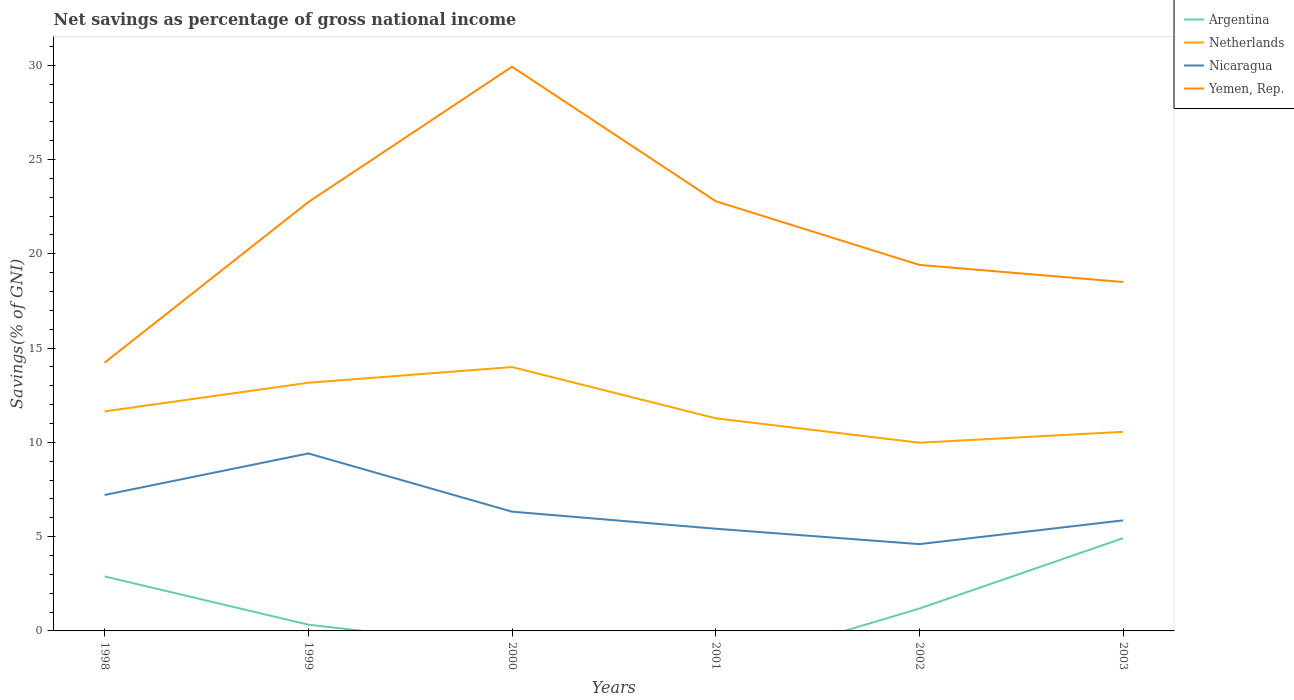Across all years, what is the maximum total savings in Netherlands?
Ensure brevity in your answer.  9.98. What is the total total savings in Nicaragua in the graph?
Offer a terse response. 0.89. What is the difference between the highest and the second highest total savings in Argentina?
Ensure brevity in your answer.  4.92. Is the total savings in Argentina strictly greater than the total savings in Netherlands over the years?
Provide a succinct answer. Yes. How many lines are there?
Give a very brief answer. 4. How many years are there in the graph?
Provide a short and direct response. 6. What is the difference between two consecutive major ticks on the Y-axis?
Offer a very short reply. 5. Are the values on the major ticks of Y-axis written in scientific E-notation?
Provide a short and direct response. No. Does the graph contain any zero values?
Offer a terse response. Yes. How many legend labels are there?
Ensure brevity in your answer.  4. How are the legend labels stacked?
Give a very brief answer. Vertical. What is the title of the graph?
Your answer should be compact. Net savings as percentage of gross national income. What is the label or title of the X-axis?
Keep it short and to the point. Years. What is the label or title of the Y-axis?
Your response must be concise. Savings(% of GNI). What is the Savings(% of GNI) of Argentina in 1998?
Ensure brevity in your answer.  2.89. What is the Savings(% of GNI) in Netherlands in 1998?
Ensure brevity in your answer.  11.64. What is the Savings(% of GNI) in Nicaragua in 1998?
Make the answer very short. 7.21. What is the Savings(% of GNI) in Yemen, Rep. in 1998?
Your response must be concise. 14.23. What is the Savings(% of GNI) of Argentina in 1999?
Keep it short and to the point. 0.33. What is the Savings(% of GNI) in Netherlands in 1999?
Make the answer very short. 13.16. What is the Savings(% of GNI) in Nicaragua in 1999?
Offer a very short reply. 9.41. What is the Savings(% of GNI) in Yemen, Rep. in 1999?
Give a very brief answer. 22.74. What is the Savings(% of GNI) of Netherlands in 2000?
Make the answer very short. 13.99. What is the Savings(% of GNI) of Nicaragua in 2000?
Keep it short and to the point. 6.33. What is the Savings(% of GNI) in Yemen, Rep. in 2000?
Provide a short and direct response. 29.92. What is the Savings(% of GNI) of Argentina in 2001?
Offer a very short reply. 0. What is the Savings(% of GNI) in Netherlands in 2001?
Keep it short and to the point. 11.28. What is the Savings(% of GNI) in Nicaragua in 2001?
Give a very brief answer. 5.42. What is the Savings(% of GNI) of Yemen, Rep. in 2001?
Your answer should be compact. 22.79. What is the Savings(% of GNI) in Argentina in 2002?
Your answer should be very brief. 1.19. What is the Savings(% of GNI) of Netherlands in 2002?
Offer a very short reply. 9.98. What is the Savings(% of GNI) in Nicaragua in 2002?
Provide a succinct answer. 4.6. What is the Savings(% of GNI) in Yemen, Rep. in 2002?
Your response must be concise. 19.41. What is the Savings(% of GNI) in Argentina in 2003?
Offer a very short reply. 4.92. What is the Savings(% of GNI) of Netherlands in 2003?
Provide a succinct answer. 10.56. What is the Savings(% of GNI) of Nicaragua in 2003?
Provide a short and direct response. 5.86. What is the Savings(% of GNI) of Yemen, Rep. in 2003?
Your response must be concise. 18.51. Across all years, what is the maximum Savings(% of GNI) of Argentina?
Provide a succinct answer. 4.92. Across all years, what is the maximum Savings(% of GNI) in Netherlands?
Ensure brevity in your answer.  13.99. Across all years, what is the maximum Savings(% of GNI) in Nicaragua?
Offer a very short reply. 9.41. Across all years, what is the maximum Savings(% of GNI) in Yemen, Rep.?
Your answer should be very brief. 29.92. Across all years, what is the minimum Savings(% of GNI) in Argentina?
Ensure brevity in your answer.  0. Across all years, what is the minimum Savings(% of GNI) of Netherlands?
Offer a terse response. 9.98. Across all years, what is the minimum Savings(% of GNI) of Nicaragua?
Your answer should be compact. 4.6. Across all years, what is the minimum Savings(% of GNI) of Yemen, Rep.?
Ensure brevity in your answer.  14.23. What is the total Savings(% of GNI) in Argentina in the graph?
Give a very brief answer. 9.33. What is the total Savings(% of GNI) of Netherlands in the graph?
Your answer should be very brief. 70.62. What is the total Savings(% of GNI) in Nicaragua in the graph?
Make the answer very short. 38.83. What is the total Savings(% of GNI) of Yemen, Rep. in the graph?
Your answer should be compact. 127.6. What is the difference between the Savings(% of GNI) in Argentina in 1998 and that in 1999?
Give a very brief answer. 2.56. What is the difference between the Savings(% of GNI) in Netherlands in 1998 and that in 1999?
Keep it short and to the point. -1.52. What is the difference between the Savings(% of GNI) of Nicaragua in 1998 and that in 1999?
Your response must be concise. -2.2. What is the difference between the Savings(% of GNI) of Yemen, Rep. in 1998 and that in 1999?
Give a very brief answer. -8.51. What is the difference between the Savings(% of GNI) of Netherlands in 1998 and that in 2000?
Give a very brief answer. -2.35. What is the difference between the Savings(% of GNI) of Nicaragua in 1998 and that in 2000?
Offer a very short reply. 0.89. What is the difference between the Savings(% of GNI) in Yemen, Rep. in 1998 and that in 2000?
Make the answer very short. -15.7. What is the difference between the Savings(% of GNI) in Netherlands in 1998 and that in 2001?
Your answer should be compact. 0.37. What is the difference between the Savings(% of GNI) of Nicaragua in 1998 and that in 2001?
Your answer should be compact. 1.79. What is the difference between the Savings(% of GNI) in Yemen, Rep. in 1998 and that in 2001?
Your response must be concise. -8.56. What is the difference between the Savings(% of GNI) of Argentina in 1998 and that in 2002?
Give a very brief answer. 1.7. What is the difference between the Savings(% of GNI) in Netherlands in 1998 and that in 2002?
Your answer should be compact. 1.66. What is the difference between the Savings(% of GNI) in Nicaragua in 1998 and that in 2002?
Give a very brief answer. 2.61. What is the difference between the Savings(% of GNI) in Yemen, Rep. in 1998 and that in 2002?
Provide a succinct answer. -5.18. What is the difference between the Savings(% of GNI) in Argentina in 1998 and that in 2003?
Your answer should be compact. -2.03. What is the difference between the Savings(% of GNI) of Netherlands in 1998 and that in 2003?
Your answer should be very brief. 1.08. What is the difference between the Savings(% of GNI) in Nicaragua in 1998 and that in 2003?
Ensure brevity in your answer.  1.35. What is the difference between the Savings(% of GNI) of Yemen, Rep. in 1998 and that in 2003?
Make the answer very short. -4.28. What is the difference between the Savings(% of GNI) of Netherlands in 1999 and that in 2000?
Provide a short and direct response. -0.83. What is the difference between the Savings(% of GNI) of Nicaragua in 1999 and that in 2000?
Keep it short and to the point. 3.09. What is the difference between the Savings(% of GNI) of Yemen, Rep. in 1999 and that in 2000?
Offer a very short reply. -7.18. What is the difference between the Savings(% of GNI) of Netherlands in 1999 and that in 2001?
Keep it short and to the point. 1.88. What is the difference between the Savings(% of GNI) in Nicaragua in 1999 and that in 2001?
Make the answer very short. 3.99. What is the difference between the Savings(% of GNI) in Yemen, Rep. in 1999 and that in 2001?
Offer a very short reply. -0.05. What is the difference between the Savings(% of GNI) of Argentina in 1999 and that in 2002?
Offer a very short reply. -0.85. What is the difference between the Savings(% of GNI) of Netherlands in 1999 and that in 2002?
Provide a short and direct response. 3.18. What is the difference between the Savings(% of GNI) in Nicaragua in 1999 and that in 2002?
Offer a terse response. 4.81. What is the difference between the Savings(% of GNI) in Yemen, Rep. in 1999 and that in 2002?
Give a very brief answer. 3.33. What is the difference between the Savings(% of GNI) of Argentina in 1999 and that in 2003?
Ensure brevity in your answer.  -4.59. What is the difference between the Savings(% of GNI) of Netherlands in 1999 and that in 2003?
Offer a terse response. 2.6. What is the difference between the Savings(% of GNI) of Nicaragua in 1999 and that in 2003?
Your answer should be very brief. 3.55. What is the difference between the Savings(% of GNI) in Yemen, Rep. in 1999 and that in 2003?
Provide a short and direct response. 4.24. What is the difference between the Savings(% of GNI) in Netherlands in 2000 and that in 2001?
Your answer should be very brief. 2.72. What is the difference between the Savings(% of GNI) of Nicaragua in 2000 and that in 2001?
Ensure brevity in your answer.  0.91. What is the difference between the Savings(% of GNI) of Yemen, Rep. in 2000 and that in 2001?
Ensure brevity in your answer.  7.13. What is the difference between the Savings(% of GNI) of Netherlands in 2000 and that in 2002?
Provide a succinct answer. 4.01. What is the difference between the Savings(% of GNI) in Nicaragua in 2000 and that in 2002?
Ensure brevity in your answer.  1.72. What is the difference between the Savings(% of GNI) in Yemen, Rep. in 2000 and that in 2002?
Your response must be concise. 10.51. What is the difference between the Savings(% of GNI) of Netherlands in 2000 and that in 2003?
Your answer should be very brief. 3.43. What is the difference between the Savings(% of GNI) in Nicaragua in 2000 and that in 2003?
Provide a short and direct response. 0.46. What is the difference between the Savings(% of GNI) in Yemen, Rep. in 2000 and that in 2003?
Provide a succinct answer. 11.42. What is the difference between the Savings(% of GNI) of Netherlands in 2001 and that in 2002?
Make the answer very short. 1.3. What is the difference between the Savings(% of GNI) of Nicaragua in 2001 and that in 2002?
Give a very brief answer. 0.82. What is the difference between the Savings(% of GNI) of Yemen, Rep. in 2001 and that in 2002?
Offer a very short reply. 3.38. What is the difference between the Savings(% of GNI) in Netherlands in 2001 and that in 2003?
Provide a succinct answer. 0.72. What is the difference between the Savings(% of GNI) of Nicaragua in 2001 and that in 2003?
Your answer should be compact. -0.44. What is the difference between the Savings(% of GNI) in Yemen, Rep. in 2001 and that in 2003?
Provide a short and direct response. 4.29. What is the difference between the Savings(% of GNI) in Argentina in 2002 and that in 2003?
Ensure brevity in your answer.  -3.73. What is the difference between the Savings(% of GNI) of Netherlands in 2002 and that in 2003?
Your answer should be compact. -0.58. What is the difference between the Savings(% of GNI) in Nicaragua in 2002 and that in 2003?
Your answer should be compact. -1.26. What is the difference between the Savings(% of GNI) in Yemen, Rep. in 2002 and that in 2003?
Your response must be concise. 0.91. What is the difference between the Savings(% of GNI) of Argentina in 1998 and the Savings(% of GNI) of Netherlands in 1999?
Keep it short and to the point. -10.27. What is the difference between the Savings(% of GNI) of Argentina in 1998 and the Savings(% of GNI) of Nicaragua in 1999?
Give a very brief answer. -6.52. What is the difference between the Savings(% of GNI) of Argentina in 1998 and the Savings(% of GNI) of Yemen, Rep. in 1999?
Provide a short and direct response. -19.85. What is the difference between the Savings(% of GNI) of Netherlands in 1998 and the Savings(% of GNI) of Nicaragua in 1999?
Offer a terse response. 2.23. What is the difference between the Savings(% of GNI) in Netherlands in 1998 and the Savings(% of GNI) in Yemen, Rep. in 1999?
Keep it short and to the point. -11.1. What is the difference between the Savings(% of GNI) of Nicaragua in 1998 and the Savings(% of GNI) of Yemen, Rep. in 1999?
Your answer should be compact. -15.53. What is the difference between the Savings(% of GNI) of Argentina in 1998 and the Savings(% of GNI) of Netherlands in 2000?
Provide a short and direct response. -11.1. What is the difference between the Savings(% of GNI) of Argentina in 1998 and the Savings(% of GNI) of Nicaragua in 2000?
Keep it short and to the point. -3.43. What is the difference between the Savings(% of GNI) in Argentina in 1998 and the Savings(% of GNI) in Yemen, Rep. in 2000?
Offer a terse response. -27.03. What is the difference between the Savings(% of GNI) of Netherlands in 1998 and the Savings(% of GNI) of Nicaragua in 2000?
Provide a succinct answer. 5.32. What is the difference between the Savings(% of GNI) of Netherlands in 1998 and the Savings(% of GNI) of Yemen, Rep. in 2000?
Your response must be concise. -18.28. What is the difference between the Savings(% of GNI) in Nicaragua in 1998 and the Savings(% of GNI) in Yemen, Rep. in 2000?
Provide a succinct answer. -22.71. What is the difference between the Savings(% of GNI) in Argentina in 1998 and the Savings(% of GNI) in Netherlands in 2001?
Provide a succinct answer. -8.39. What is the difference between the Savings(% of GNI) of Argentina in 1998 and the Savings(% of GNI) of Nicaragua in 2001?
Your answer should be very brief. -2.53. What is the difference between the Savings(% of GNI) of Argentina in 1998 and the Savings(% of GNI) of Yemen, Rep. in 2001?
Provide a succinct answer. -19.9. What is the difference between the Savings(% of GNI) of Netherlands in 1998 and the Savings(% of GNI) of Nicaragua in 2001?
Provide a short and direct response. 6.22. What is the difference between the Savings(% of GNI) in Netherlands in 1998 and the Savings(% of GNI) in Yemen, Rep. in 2001?
Offer a terse response. -11.15. What is the difference between the Savings(% of GNI) in Nicaragua in 1998 and the Savings(% of GNI) in Yemen, Rep. in 2001?
Keep it short and to the point. -15.58. What is the difference between the Savings(% of GNI) in Argentina in 1998 and the Savings(% of GNI) in Netherlands in 2002?
Ensure brevity in your answer.  -7.09. What is the difference between the Savings(% of GNI) in Argentina in 1998 and the Savings(% of GNI) in Nicaragua in 2002?
Offer a terse response. -1.71. What is the difference between the Savings(% of GNI) of Argentina in 1998 and the Savings(% of GNI) of Yemen, Rep. in 2002?
Keep it short and to the point. -16.52. What is the difference between the Savings(% of GNI) in Netherlands in 1998 and the Savings(% of GNI) in Nicaragua in 2002?
Make the answer very short. 7.04. What is the difference between the Savings(% of GNI) in Netherlands in 1998 and the Savings(% of GNI) in Yemen, Rep. in 2002?
Make the answer very short. -7.77. What is the difference between the Savings(% of GNI) in Nicaragua in 1998 and the Savings(% of GNI) in Yemen, Rep. in 2002?
Provide a short and direct response. -12.2. What is the difference between the Savings(% of GNI) in Argentina in 1998 and the Savings(% of GNI) in Netherlands in 2003?
Offer a terse response. -7.67. What is the difference between the Savings(% of GNI) of Argentina in 1998 and the Savings(% of GNI) of Nicaragua in 2003?
Your answer should be compact. -2.97. What is the difference between the Savings(% of GNI) of Argentina in 1998 and the Savings(% of GNI) of Yemen, Rep. in 2003?
Provide a succinct answer. -15.61. What is the difference between the Savings(% of GNI) of Netherlands in 1998 and the Savings(% of GNI) of Nicaragua in 2003?
Your answer should be compact. 5.78. What is the difference between the Savings(% of GNI) of Netherlands in 1998 and the Savings(% of GNI) of Yemen, Rep. in 2003?
Give a very brief answer. -6.86. What is the difference between the Savings(% of GNI) in Nicaragua in 1998 and the Savings(% of GNI) in Yemen, Rep. in 2003?
Provide a succinct answer. -11.29. What is the difference between the Savings(% of GNI) of Argentina in 1999 and the Savings(% of GNI) of Netherlands in 2000?
Make the answer very short. -13.66. What is the difference between the Savings(% of GNI) of Argentina in 1999 and the Savings(% of GNI) of Nicaragua in 2000?
Offer a terse response. -5.99. What is the difference between the Savings(% of GNI) of Argentina in 1999 and the Savings(% of GNI) of Yemen, Rep. in 2000?
Provide a short and direct response. -29.59. What is the difference between the Savings(% of GNI) of Netherlands in 1999 and the Savings(% of GNI) of Nicaragua in 2000?
Keep it short and to the point. 6.84. What is the difference between the Savings(% of GNI) of Netherlands in 1999 and the Savings(% of GNI) of Yemen, Rep. in 2000?
Your answer should be very brief. -16.76. What is the difference between the Savings(% of GNI) in Nicaragua in 1999 and the Savings(% of GNI) in Yemen, Rep. in 2000?
Keep it short and to the point. -20.51. What is the difference between the Savings(% of GNI) in Argentina in 1999 and the Savings(% of GNI) in Netherlands in 2001?
Offer a terse response. -10.94. What is the difference between the Savings(% of GNI) of Argentina in 1999 and the Savings(% of GNI) of Nicaragua in 2001?
Keep it short and to the point. -5.09. What is the difference between the Savings(% of GNI) in Argentina in 1999 and the Savings(% of GNI) in Yemen, Rep. in 2001?
Keep it short and to the point. -22.46. What is the difference between the Savings(% of GNI) in Netherlands in 1999 and the Savings(% of GNI) in Nicaragua in 2001?
Make the answer very short. 7.74. What is the difference between the Savings(% of GNI) of Netherlands in 1999 and the Savings(% of GNI) of Yemen, Rep. in 2001?
Your answer should be very brief. -9.63. What is the difference between the Savings(% of GNI) of Nicaragua in 1999 and the Savings(% of GNI) of Yemen, Rep. in 2001?
Provide a succinct answer. -13.38. What is the difference between the Savings(% of GNI) in Argentina in 1999 and the Savings(% of GNI) in Netherlands in 2002?
Offer a terse response. -9.65. What is the difference between the Savings(% of GNI) in Argentina in 1999 and the Savings(% of GNI) in Nicaragua in 2002?
Your response must be concise. -4.27. What is the difference between the Savings(% of GNI) in Argentina in 1999 and the Savings(% of GNI) in Yemen, Rep. in 2002?
Keep it short and to the point. -19.08. What is the difference between the Savings(% of GNI) of Netherlands in 1999 and the Savings(% of GNI) of Nicaragua in 2002?
Your answer should be very brief. 8.56. What is the difference between the Savings(% of GNI) in Netherlands in 1999 and the Savings(% of GNI) in Yemen, Rep. in 2002?
Offer a terse response. -6.25. What is the difference between the Savings(% of GNI) in Nicaragua in 1999 and the Savings(% of GNI) in Yemen, Rep. in 2002?
Offer a terse response. -10. What is the difference between the Savings(% of GNI) in Argentina in 1999 and the Savings(% of GNI) in Netherlands in 2003?
Keep it short and to the point. -10.23. What is the difference between the Savings(% of GNI) of Argentina in 1999 and the Savings(% of GNI) of Nicaragua in 2003?
Make the answer very short. -5.53. What is the difference between the Savings(% of GNI) in Argentina in 1999 and the Savings(% of GNI) in Yemen, Rep. in 2003?
Your answer should be very brief. -18.17. What is the difference between the Savings(% of GNI) in Netherlands in 1999 and the Savings(% of GNI) in Nicaragua in 2003?
Keep it short and to the point. 7.3. What is the difference between the Savings(% of GNI) in Netherlands in 1999 and the Savings(% of GNI) in Yemen, Rep. in 2003?
Provide a short and direct response. -5.34. What is the difference between the Savings(% of GNI) in Nicaragua in 1999 and the Savings(% of GNI) in Yemen, Rep. in 2003?
Keep it short and to the point. -9.09. What is the difference between the Savings(% of GNI) of Netherlands in 2000 and the Savings(% of GNI) of Nicaragua in 2001?
Offer a terse response. 8.57. What is the difference between the Savings(% of GNI) in Netherlands in 2000 and the Savings(% of GNI) in Yemen, Rep. in 2001?
Provide a short and direct response. -8.8. What is the difference between the Savings(% of GNI) in Nicaragua in 2000 and the Savings(% of GNI) in Yemen, Rep. in 2001?
Your answer should be compact. -16.47. What is the difference between the Savings(% of GNI) in Netherlands in 2000 and the Savings(% of GNI) in Nicaragua in 2002?
Keep it short and to the point. 9.39. What is the difference between the Savings(% of GNI) of Netherlands in 2000 and the Savings(% of GNI) of Yemen, Rep. in 2002?
Provide a succinct answer. -5.42. What is the difference between the Savings(% of GNI) in Nicaragua in 2000 and the Savings(% of GNI) in Yemen, Rep. in 2002?
Provide a succinct answer. -13.09. What is the difference between the Savings(% of GNI) of Netherlands in 2000 and the Savings(% of GNI) of Nicaragua in 2003?
Give a very brief answer. 8.13. What is the difference between the Savings(% of GNI) of Netherlands in 2000 and the Savings(% of GNI) of Yemen, Rep. in 2003?
Make the answer very short. -4.51. What is the difference between the Savings(% of GNI) in Nicaragua in 2000 and the Savings(% of GNI) in Yemen, Rep. in 2003?
Your answer should be very brief. -12.18. What is the difference between the Savings(% of GNI) of Netherlands in 2001 and the Savings(% of GNI) of Nicaragua in 2002?
Your answer should be very brief. 6.67. What is the difference between the Savings(% of GNI) of Netherlands in 2001 and the Savings(% of GNI) of Yemen, Rep. in 2002?
Provide a short and direct response. -8.13. What is the difference between the Savings(% of GNI) in Nicaragua in 2001 and the Savings(% of GNI) in Yemen, Rep. in 2002?
Offer a terse response. -13.99. What is the difference between the Savings(% of GNI) of Netherlands in 2001 and the Savings(% of GNI) of Nicaragua in 2003?
Provide a succinct answer. 5.41. What is the difference between the Savings(% of GNI) in Netherlands in 2001 and the Savings(% of GNI) in Yemen, Rep. in 2003?
Your answer should be compact. -7.23. What is the difference between the Savings(% of GNI) of Nicaragua in 2001 and the Savings(% of GNI) of Yemen, Rep. in 2003?
Ensure brevity in your answer.  -13.09. What is the difference between the Savings(% of GNI) of Argentina in 2002 and the Savings(% of GNI) of Netherlands in 2003?
Your response must be concise. -9.37. What is the difference between the Savings(% of GNI) of Argentina in 2002 and the Savings(% of GNI) of Nicaragua in 2003?
Provide a succinct answer. -4.68. What is the difference between the Savings(% of GNI) in Argentina in 2002 and the Savings(% of GNI) in Yemen, Rep. in 2003?
Provide a short and direct response. -17.32. What is the difference between the Savings(% of GNI) in Netherlands in 2002 and the Savings(% of GNI) in Nicaragua in 2003?
Give a very brief answer. 4.12. What is the difference between the Savings(% of GNI) in Netherlands in 2002 and the Savings(% of GNI) in Yemen, Rep. in 2003?
Your answer should be very brief. -8.52. What is the difference between the Savings(% of GNI) of Nicaragua in 2002 and the Savings(% of GNI) of Yemen, Rep. in 2003?
Keep it short and to the point. -13.9. What is the average Savings(% of GNI) of Argentina per year?
Your answer should be very brief. 1.55. What is the average Savings(% of GNI) in Netherlands per year?
Keep it short and to the point. 11.77. What is the average Savings(% of GNI) of Nicaragua per year?
Offer a terse response. 6.47. What is the average Savings(% of GNI) of Yemen, Rep. per year?
Your answer should be very brief. 21.27. In the year 1998, what is the difference between the Savings(% of GNI) in Argentina and Savings(% of GNI) in Netherlands?
Make the answer very short. -8.75. In the year 1998, what is the difference between the Savings(% of GNI) in Argentina and Savings(% of GNI) in Nicaragua?
Offer a very short reply. -4.32. In the year 1998, what is the difference between the Savings(% of GNI) in Argentina and Savings(% of GNI) in Yemen, Rep.?
Ensure brevity in your answer.  -11.34. In the year 1998, what is the difference between the Savings(% of GNI) in Netherlands and Savings(% of GNI) in Nicaragua?
Give a very brief answer. 4.43. In the year 1998, what is the difference between the Savings(% of GNI) of Netherlands and Savings(% of GNI) of Yemen, Rep.?
Give a very brief answer. -2.58. In the year 1998, what is the difference between the Savings(% of GNI) in Nicaragua and Savings(% of GNI) in Yemen, Rep.?
Ensure brevity in your answer.  -7.02. In the year 1999, what is the difference between the Savings(% of GNI) of Argentina and Savings(% of GNI) of Netherlands?
Your answer should be very brief. -12.83. In the year 1999, what is the difference between the Savings(% of GNI) of Argentina and Savings(% of GNI) of Nicaragua?
Give a very brief answer. -9.08. In the year 1999, what is the difference between the Savings(% of GNI) in Argentina and Savings(% of GNI) in Yemen, Rep.?
Provide a succinct answer. -22.41. In the year 1999, what is the difference between the Savings(% of GNI) in Netherlands and Savings(% of GNI) in Nicaragua?
Give a very brief answer. 3.75. In the year 1999, what is the difference between the Savings(% of GNI) of Netherlands and Savings(% of GNI) of Yemen, Rep.?
Give a very brief answer. -9.58. In the year 1999, what is the difference between the Savings(% of GNI) in Nicaragua and Savings(% of GNI) in Yemen, Rep.?
Keep it short and to the point. -13.33. In the year 2000, what is the difference between the Savings(% of GNI) in Netherlands and Savings(% of GNI) in Nicaragua?
Give a very brief answer. 7.67. In the year 2000, what is the difference between the Savings(% of GNI) of Netherlands and Savings(% of GNI) of Yemen, Rep.?
Provide a succinct answer. -15.93. In the year 2000, what is the difference between the Savings(% of GNI) in Nicaragua and Savings(% of GNI) in Yemen, Rep.?
Ensure brevity in your answer.  -23.6. In the year 2001, what is the difference between the Savings(% of GNI) of Netherlands and Savings(% of GNI) of Nicaragua?
Offer a very short reply. 5.86. In the year 2001, what is the difference between the Savings(% of GNI) in Netherlands and Savings(% of GNI) in Yemen, Rep.?
Provide a short and direct response. -11.51. In the year 2001, what is the difference between the Savings(% of GNI) in Nicaragua and Savings(% of GNI) in Yemen, Rep.?
Offer a terse response. -17.37. In the year 2002, what is the difference between the Savings(% of GNI) in Argentina and Savings(% of GNI) in Netherlands?
Your response must be concise. -8.79. In the year 2002, what is the difference between the Savings(% of GNI) in Argentina and Savings(% of GNI) in Nicaragua?
Provide a succinct answer. -3.42. In the year 2002, what is the difference between the Savings(% of GNI) in Argentina and Savings(% of GNI) in Yemen, Rep.?
Offer a very short reply. -18.23. In the year 2002, what is the difference between the Savings(% of GNI) of Netherlands and Savings(% of GNI) of Nicaragua?
Your answer should be very brief. 5.38. In the year 2002, what is the difference between the Savings(% of GNI) in Netherlands and Savings(% of GNI) in Yemen, Rep.?
Offer a very short reply. -9.43. In the year 2002, what is the difference between the Savings(% of GNI) in Nicaragua and Savings(% of GNI) in Yemen, Rep.?
Keep it short and to the point. -14.81. In the year 2003, what is the difference between the Savings(% of GNI) of Argentina and Savings(% of GNI) of Netherlands?
Make the answer very short. -5.64. In the year 2003, what is the difference between the Savings(% of GNI) in Argentina and Savings(% of GNI) in Nicaragua?
Offer a very short reply. -0.94. In the year 2003, what is the difference between the Savings(% of GNI) in Argentina and Savings(% of GNI) in Yemen, Rep.?
Your response must be concise. -13.59. In the year 2003, what is the difference between the Savings(% of GNI) in Netherlands and Savings(% of GNI) in Nicaragua?
Ensure brevity in your answer.  4.7. In the year 2003, what is the difference between the Savings(% of GNI) in Netherlands and Savings(% of GNI) in Yemen, Rep.?
Provide a succinct answer. -7.95. In the year 2003, what is the difference between the Savings(% of GNI) of Nicaragua and Savings(% of GNI) of Yemen, Rep.?
Offer a terse response. -12.64. What is the ratio of the Savings(% of GNI) of Argentina in 1998 to that in 1999?
Your answer should be very brief. 8.69. What is the ratio of the Savings(% of GNI) of Netherlands in 1998 to that in 1999?
Provide a short and direct response. 0.88. What is the ratio of the Savings(% of GNI) in Nicaragua in 1998 to that in 1999?
Keep it short and to the point. 0.77. What is the ratio of the Savings(% of GNI) of Yemen, Rep. in 1998 to that in 1999?
Provide a short and direct response. 0.63. What is the ratio of the Savings(% of GNI) of Netherlands in 1998 to that in 2000?
Make the answer very short. 0.83. What is the ratio of the Savings(% of GNI) of Nicaragua in 1998 to that in 2000?
Give a very brief answer. 1.14. What is the ratio of the Savings(% of GNI) in Yemen, Rep. in 1998 to that in 2000?
Provide a succinct answer. 0.48. What is the ratio of the Savings(% of GNI) in Netherlands in 1998 to that in 2001?
Offer a terse response. 1.03. What is the ratio of the Savings(% of GNI) in Nicaragua in 1998 to that in 2001?
Provide a short and direct response. 1.33. What is the ratio of the Savings(% of GNI) in Yemen, Rep. in 1998 to that in 2001?
Keep it short and to the point. 0.62. What is the ratio of the Savings(% of GNI) of Argentina in 1998 to that in 2002?
Your answer should be very brief. 2.44. What is the ratio of the Savings(% of GNI) of Netherlands in 1998 to that in 2002?
Offer a very short reply. 1.17. What is the ratio of the Savings(% of GNI) in Nicaragua in 1998 to that in 2002?
Keep it short and to the point. 1.57. What is the ratio of the Savings(% of GNI) in Yemen, Rep. in 1998 to that in 2002?
Keep it short and to the point. 0.73. What is the ratio of the Savings(% of GNI) in Argentina in 1998 to that in 2003?
Your answer should be compact. 0.59. What is the ratio of the Savings(% of GNI) in Netherlands in 1998 to that in 2003?
Offer a very short reply. 1.1. What is the ratio of the Savings(% of GNI) of Nicaragua in 1998 to that in 2003?
Offer a very short reply. 1.23. What is the ratio of the Savings(% of GNI) in Yemen, Rep. in 1998 to that in 2003?
Your answer should be very brief. 0.77. What is the ratio of the Savings(% of GNI) of Netherlands in 1999 to that in 2000?
Your response must be concise. 0.94. What is the ratio of the Savings(% of GNI) of Nicaragua in 1999 to that in 2000?
Provide a short and direct response. 1.49. What is the ratio of the Savings(% of GNI) in Yemen, Rep. in 1999 to that in 2000?
Ensure brevity in your answer.  0.76. What is the ratio of the Savings(% of GNI) of Netherlands in 1999 to that in 2001?
Keep it short and to the point. 1.17. What is the ratio of the Savings(% of GNI) of Nicaragua in 1999 to that in 2001?
Give a very brief answer. 1.74. What is the ratio of the Savings(% of GNI) in Argentina in 1999 to that in 2002?
Provide a succinct answer. 0.28. What is the ratio of the Savings(% of GNI) of Netherlands in 1999 to that in 2002?
Ensure brevity in your answer.  1.32. What is the ratio of the Savings(% of GNI) of Nicaragua in 1999 to that in 2002?
Your answer should be compact. 2.04. What is the ratio of the Savings(% of GNI) in Yemen, Rep. in 1999 to that in 2002?
Ensure brevity in your answer.  1.17. What is the ratio of the Savings(% of GNI) of Argentina in 1999 to that in 2003?
Offer a terse response. 0.07. What is the ratio of the Savings(% of GNI) of Netherlands in 1999 to that in 2003?
Give a very brief answer. 1.25. What is the ratio of the Savings(% of GNI) in Nicaragua in 1999 to that in 2003?
Your answer should be compact. 1.61. What is the ratio of the Savings(% of GNI) in Yemen, Rep. in 1999 to that in 2003?
Provide a succinct answer. 1.23. What is the ratio of the Savings(% of GNI) of Netherlands in 2000 to that in 2001?
Offer a terse response. 1.24. What is the ratio of the Savings(% of GNI) in Nicaragua in 2000 to that in 2001?
Your answer should be very brief. 1.17. What is the ratio of the Savings(% of GNI) of Yemen, Rep. in 2000 to that in 2001?
Your answer should be very brief. 1.31. What is the ratio of the Savings(% of GNI) in Netherlands in 2000 to that in 2002?
Your answer should be compact. 1.4. What is the ratio of the Savings(% of GNI) in Nicaragua in 2000 to that in 2002?
Give a very brief answer. 1.37. What is the ratio of the Savings(% of GNI) in Yemen, Rep. in 2000 to that in 2002?
Make the answer very short. 1.54. What is the ratio of the Savings(% of GNI) in Netherlands in 2000 to that in 2003?
Provide a succinct answer. 1.33. What is the ratio of the Savings(% of GNI) of Nicaragua in 2000 to that in 2003?
Your response must be concise. 1.08. What is the ratio of the Savings(% of GNI) of Yemen, Rep. in 2000 to that in 2003?
Make the answer very short. 1.62. What is the ratio of the Savings(% of GNI) in Netherlands in 2001 to that in 2002?
Give a very brief answer. 1.13. What is the ratio of the Savings(% of GNI) in Nicaragua in 2001 to that in 2002?
Your answer should be compact. 1.18. What is the ratio of the Savings(% of GNI) of Yemen, Rep. in 2001 to that in 2002?
Give a very brief answer. 1.17. What is the ratio of the Savings(% of GNI) in Netherlands in 2001 to that in 2003?
Provide a succinct answer. 1.07. What is the ratio of the Savings(% of GNI) of Nicaragua in 2001 to that in 2003?
Give a very brief answer. 0.92. What is the ratio of the Savings(% of GNI) of Yemen, Rep. in 2001 to that in 2003?
Offer a very short reply. 1.23. What is the ratio of the Savings(% of GNI) in Argentina in 2002 to that in 2003?
Give a very brief answer. 0.24. What is the ratio of the Savings(% of GNI) in Netherlands in 2002 to that in 2003?
Provide a succinct answer. 0.95. What is the ratio of the Savings(% of GNI) in Nicaragua in 2002 to that in 2003?
Keep it short and to the point. 0.79. What is the ratio of the Savings(% of GNI) in Yemen, Rep. in 2002 to that in 2003?
Ensure brevity in your answer.  1.05. What is the difference between the highest and the second highest Savings(% of GNI) of Argentina?
Your answer should be compact. 2.03. What is the difference between the highest and the second highest Savings(% of GNI) in Netherlands?
Provide a succinct answer. 0.83. What is the difference between the highest and the second highest Savings(% of GNI) in Nicaragua?
Your answer should be very brief. 2.2. What is the difference between the highest and the second highest Savings(% of GNI) of Yemen, Rep.?
Offer a terse response. 7.13. What is the difference between the highest and the lowest Savings(% of GNI) of Argentina?
Ensure brevity in your answer.  4.92. What is the difference between the highest and the lowest Savings(% of GNI) of Netherlands?
Keep it short and to the point. 4.01. What is the difference between the highest and the lowest Savings(% of GNI) in Nicaragua?
Keep it short and to the point. 4.81. What is the difference between the highest and the lowest Savings(% of GNI) in Yemen, Rep.?
Offer a terse response. 15.7. 